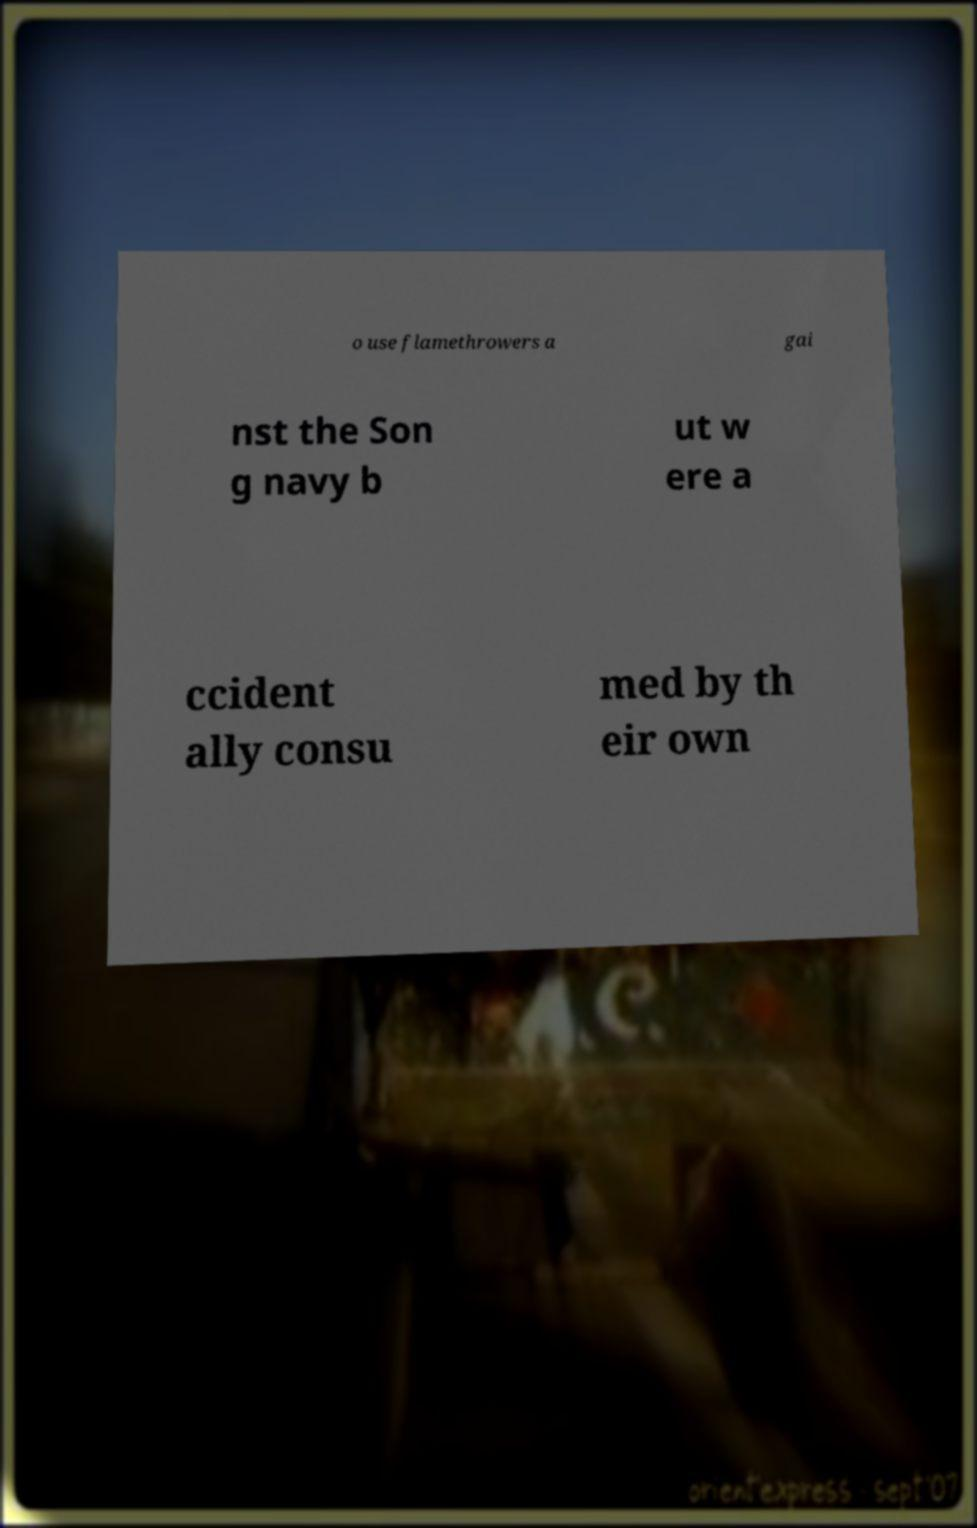Please read and relay the text visible in this image. What does it say? o use flamethrowers a gai nst the Son g navy b ut w ere a ccident ally consu med by th eir own 